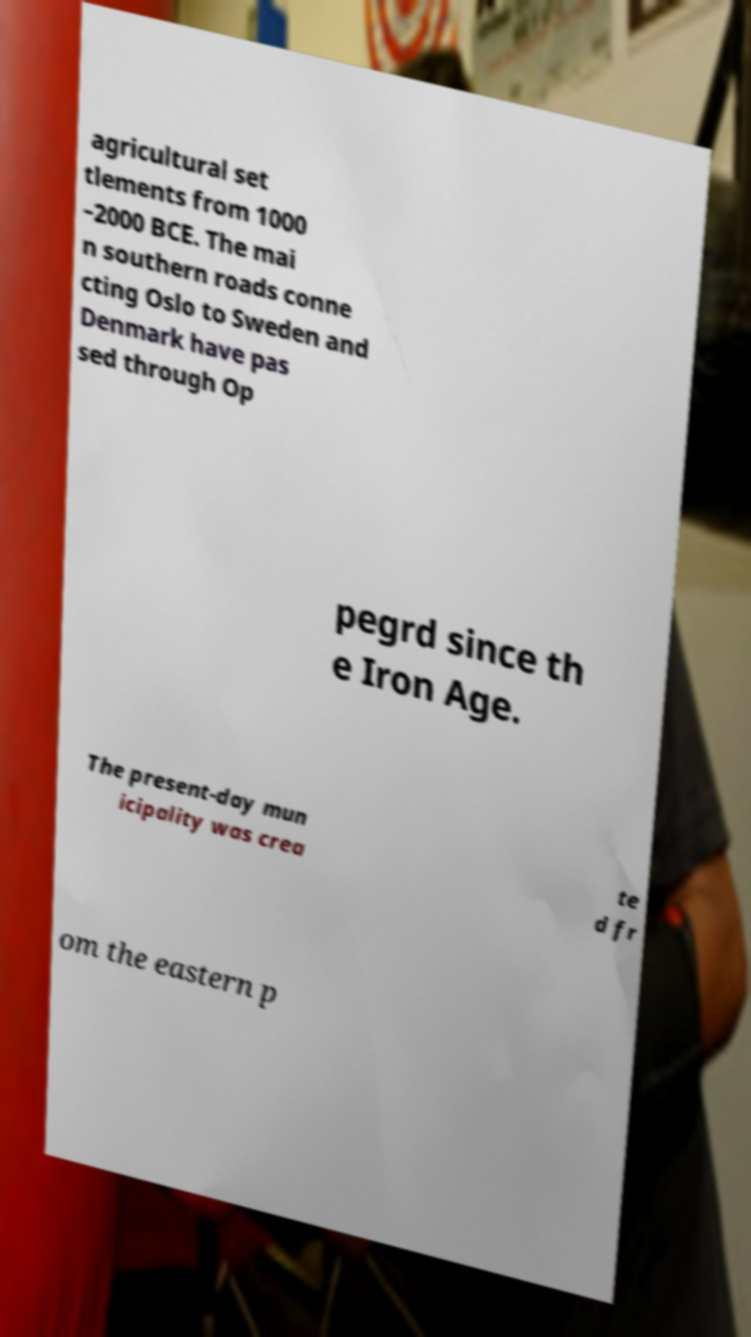Could you extract and type out the text from this image? agricultural set tlements from 1000 –2000 BCE. The mai n southern roads conne cting Oslo to Sweden and Denmark have pas sed through Op pegrd since th e Iron Age. The present-day mun icipality was crea te d fr om the eastern p 